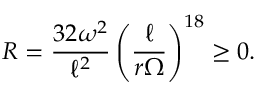<formula> <loc_0><loc_0><loc_500><loc_500>R = \frac { 3 2 \omega ^ { 2 } } { \ell ^ { 2 } } \left ( \frac { \ell } { r \Omega } \right ) ^ { 1 8 } \geq 0 .</formula> 